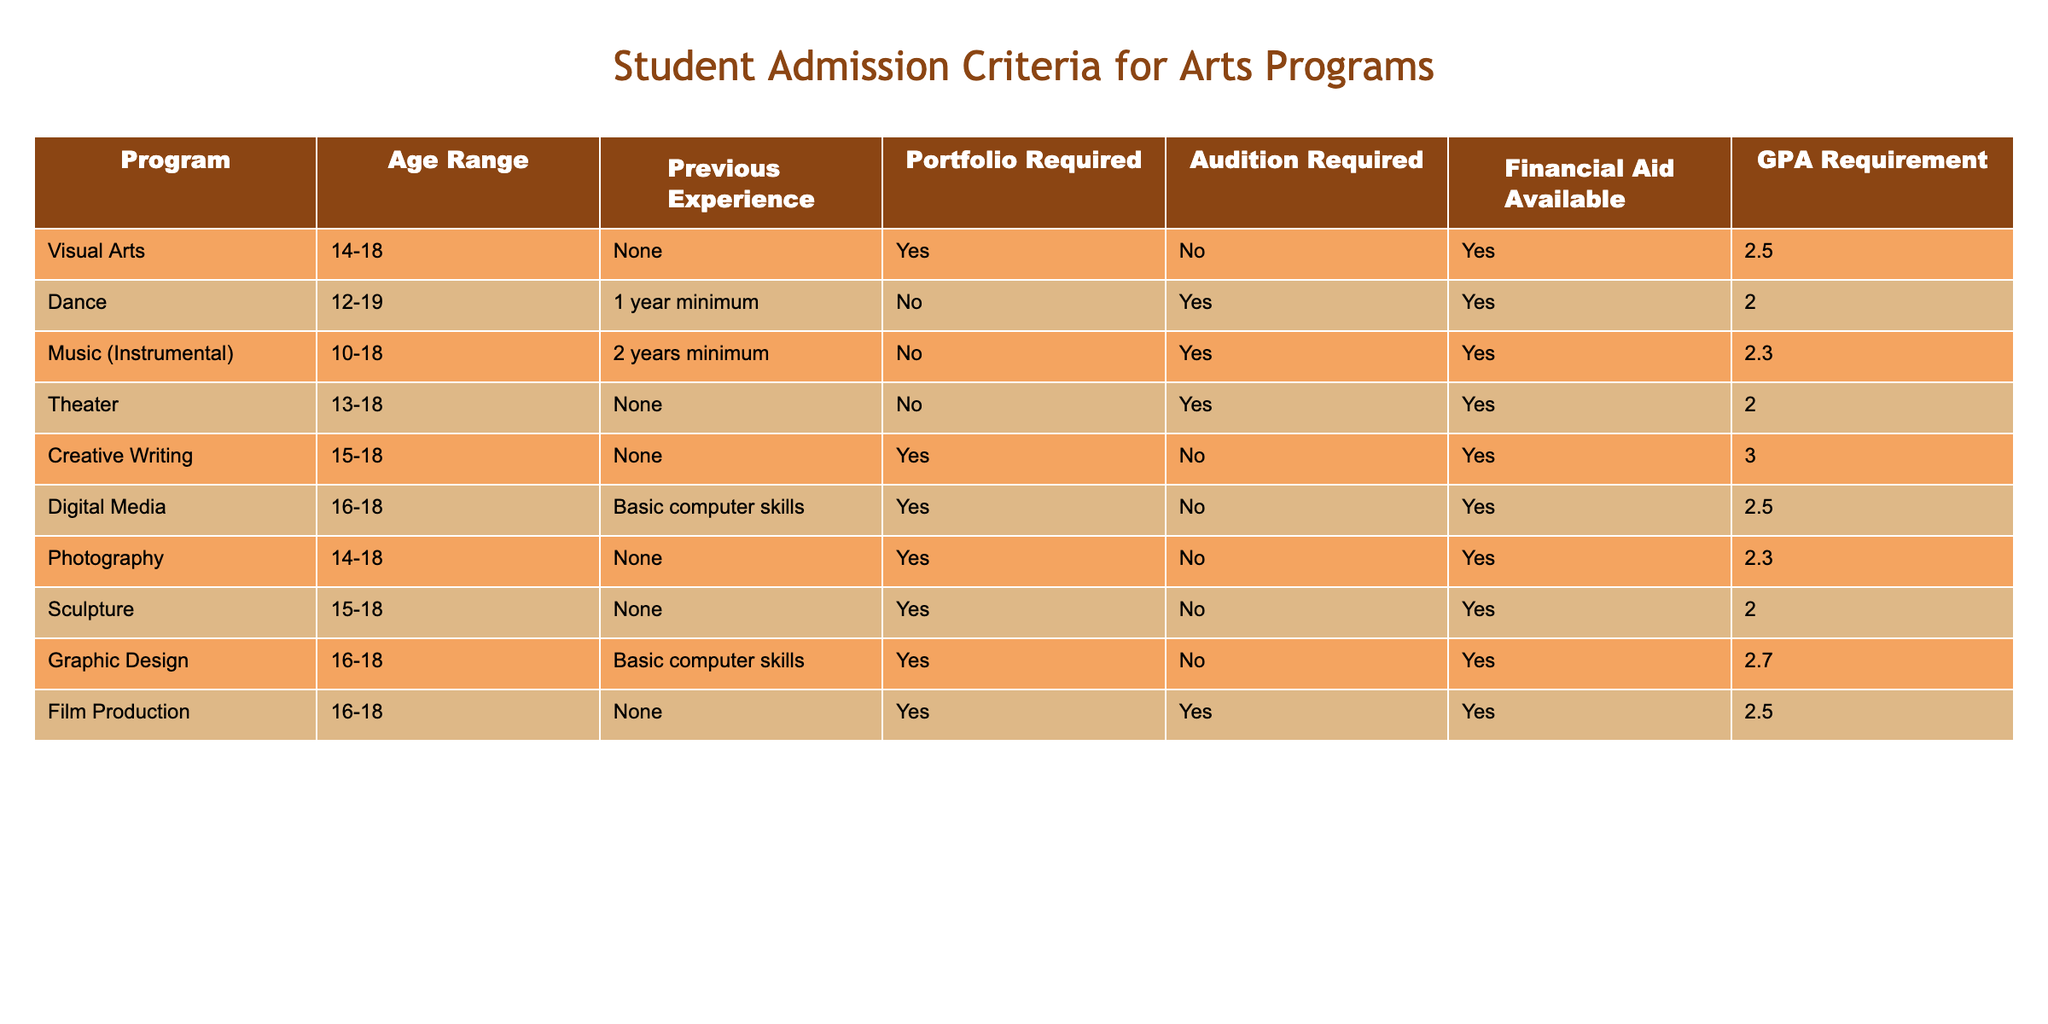What is the GPA requirement for the Dance program? The Dance program has a GPA requirement listed in the table under the "GPA Requirement" column. By locating the row for the Dance program, we find that the GPA requirement is 2.0.
Answer: 2.0 Is previous experience required for the Theater program? In the table, the "Previous Experience" column for the Theater program states "None," indicating that no prior experience is required to apply for this program.
Answer: No Which art program offers financial aid for students? To answer this, we look at the "Financial Aid Available" column across all programs. All programs listed have "Yes" in this column, thus, all offer financial aid for students.
Answer: Yes What age range is eligible for the Graphic Design program? The age eligibility for the Graphic Design program is found by checking the "Age Range" column in its respective row. It shows "16-18," which indicates the eligible age range for applicants.
Answer: 16-18 How many programs do not require an audition? In order to find this, we need to look at the "Audition Required" column and count the programs with "No" listed. Upon reviewing the data, we see that four programs (Visual Arts, Dance, Photography, Sculpture) do not require an audition.
Answer: 4 Which program has the highest GPA requirement and what is it? First, we will look at the "GPA Requirement" column and identify the highest value. The program with the highest GPA requirement is Creative Writing with a requirement of 3.0.
Answer: 3.0 Is there any program for students younger than 14? The age ranges in the table show that the lowest age eligibility starts at 10 for the Music (Instrumental) program. Therefore, there is at least one program available for students younger than 14.
Answer: Yes What percentage of programs require a portfolio? To calculate this percentage, we first count the total number of programs, which is 9. Then we count the ones requiring a portfolio, which are Visual Arts, Creative Writing, Photography, and Sculpture (total of 4). The calculation is (4/9)*100. This results in approximately 44.44%.
Answer: 44.44% Which two programs have basic computer skills as a prerequisite? In the "Previous Experience" column, we look for "Basic computer skills". The programs that list this requirement are Digital Media and Graphic Design.
Answer: Digital Media, Graphic Design 